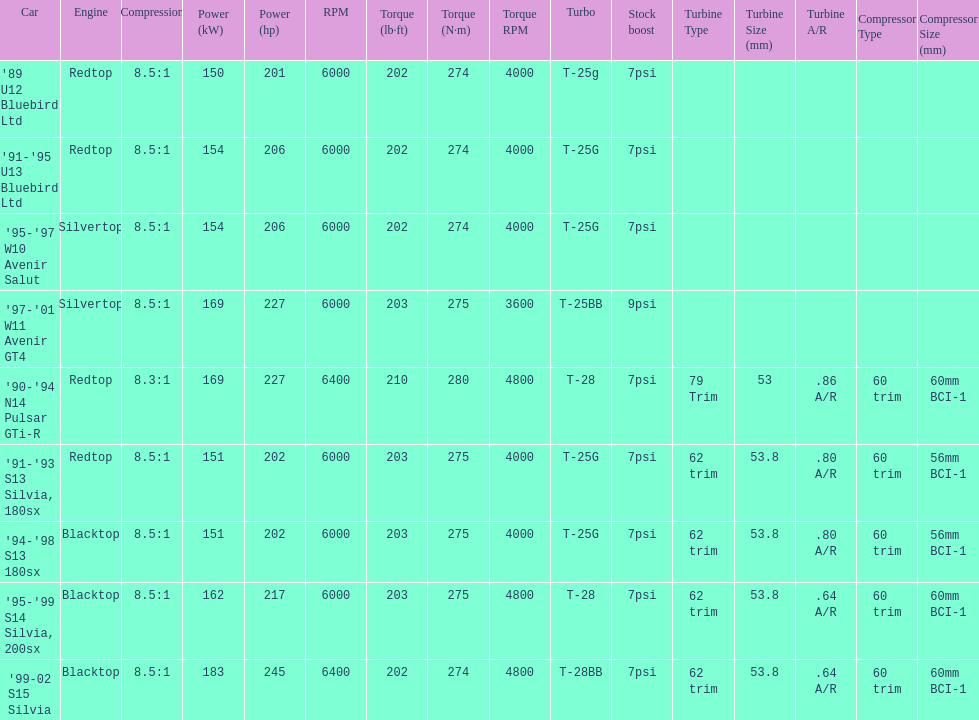Which engines were used after 1999? Silvertop, Blacktop. Could you help me parse every detail presented in this table? {'header': ['Car', 'Engine', 'Compression', 'Power (kW)', 'Power (hp)', 'RPM', 'Torque (lb·ft)', 'Torque (N·m)', 'Torque RPM', 'Turbo', 'Stock boost', 'Turbine Type', 'Turbine Size (mm)', 'Turbine A/R', 'Compressor Type', 'Compressor Size (mm)'], 'rows': [["'89 U12 Bluebird Ltd", 'Redtop', '8.5:1', '150', '201', '6000', '202', '274', '4000', 'T-25g', '7psi', '', '', '', '', ''], ["'91-'95 U13 Bluebird Ltd", 'Redtop', '8.5:1', '154', '206', '6000', '202', '274', '4000', 'T-25G', '7psi', '', '', '', '', ''], ["'95-'97 W10 Avenir Salut", 'Silvertop', '8.5:1', '154', '206', '6000', '202', '274', '4000', 'T-25G', '7psi', '', '', '', '', ''], ["'97-'01 W11 Avenir GT4", 'Silvertop', '8.5:1', '169', '227', '6000', '203', '275', '3600', 'T-25BB', '9psi', '', '', '', '', ''], ["'90-'94 N14 Pulsar GTi-R", 'Redtop', '8.3:1', '169', '227', '6400', '210', '280', '4800', 'T-28', '7psi', '79 Trim', '53', '.86 A/R', '60 trim', '60mm BCI-1'], ["'91-'93 S13 Silvia, 180sx", 'Redtop', '8.5:1', '151', '202', '6000', '203', '275', '4000', 'T-25G', '7psi', '62 trim', '53.8', '.80 A/R', '60 trim', '56mm BCI-1'], ["'94-'98 S13 180sx", 'Blacktop', '8.5:1', '151', '202', '6000', '203', '275', '4000', 'T-25G', '7psi', '62 trim', '53.8', '.80 A/R', '60 trim', '56mm BCI-1'], ["'95-'99 S14 Silvia, 200sx", 'Blacktop', '8.5:1', '162', '217', '6000', '203', '275', '4800', 'T-28', '7psi', '62 trim', '53.8', '.64 A/R', '60 trim', '60mm BCI-1'], ["'99-02 S15 Silvia", 'Blacktop', '8.5:1', '183', '245', '6400', '202', '274', '4800', 'T-28BB', '7psi', '62 trim', '53.8', '.64 A/R', '60 trim', '60mm BCI-1']]} 